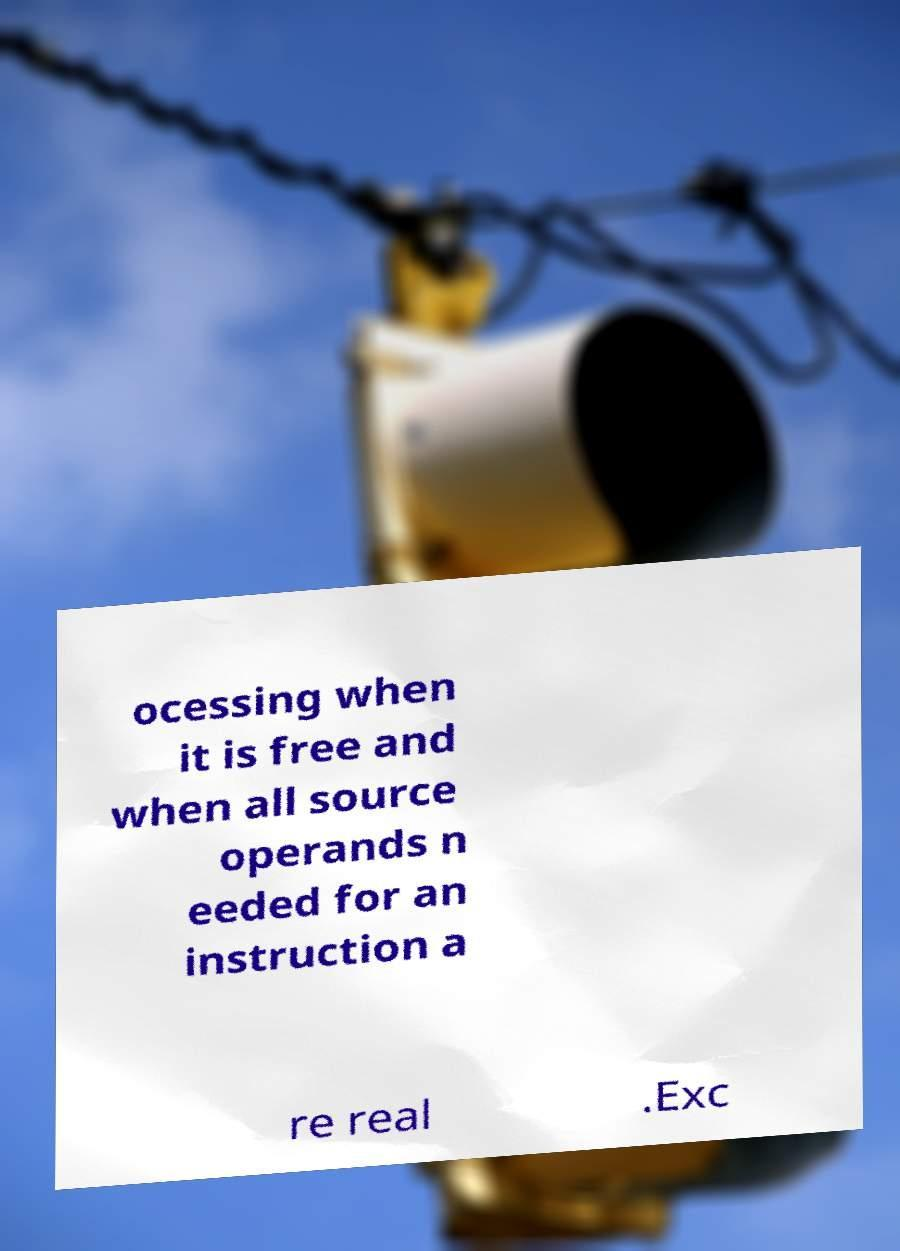What messages or text are displayed in this image? I need them in a readable, typed format. ocessing when it is free and when all source operands n eeded for an instruction a re real .Exc 